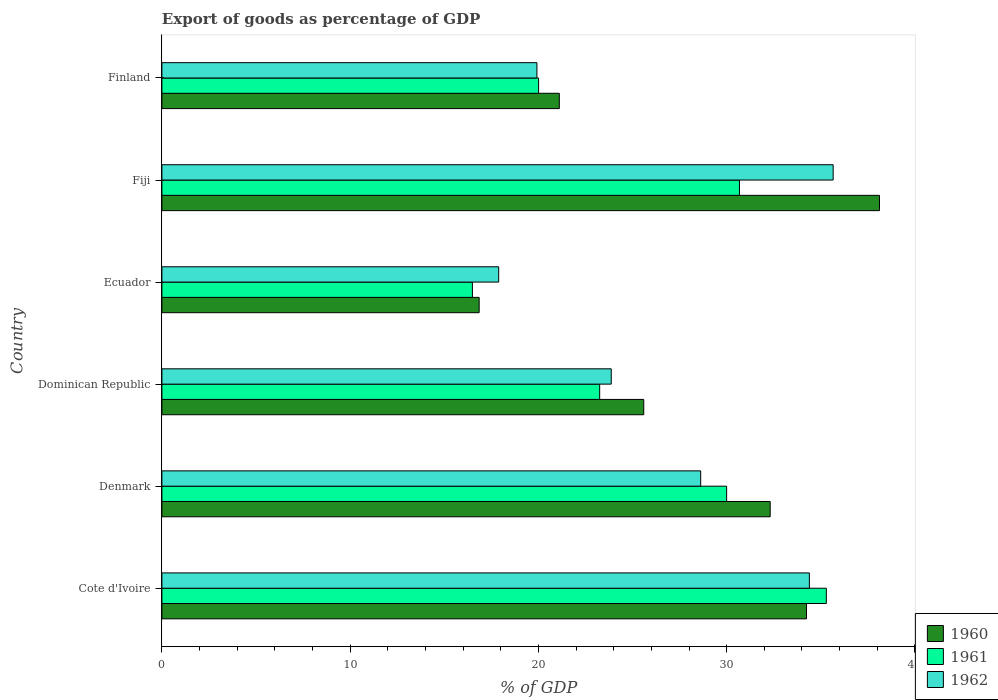How many different coloured bars are there?
Provide a succinct answer. 3. Are the number of bars on each tick of the Y-axis equal?
Provide a succinct answer. Yes. How many bars are there on the 3rd tick from the top?
Offer a terse response. 3. How many bars are there on the 4th tick from the bottom?
Your answer should be compact. 3. What is the label of the 4th group of bars from the top?
Keep it short and to the point. Dominican Republic. What is the export of goods as percentage of GDP in 1961 in Denmark?
Your answer should be compact. 30. Across all countries, what is the maximum export of goods as percentage of GDP in 1962?
Your answer should be very brief. 35.66. Across all countries, what is the minimum export of goods as percentage of GDP in 1961?
Your answer should be very brief. 16.49. In which country was the export of goods as percentage of GDP in 1960 maximum?
Provide a succinct answer. Fiji. In which country was the export of goods as percentage of GDP in 1960 minimum?
Your answer should be compact. Ecuador. What is the total export of goods as percentage of GDP in 1962 in the graph?
Provide a succinct answer. 160.35. What is the difference between the export of goods as percentage of GDP in 1962 in Dominican Republic and that in Fiji?
Your answer should be very brief. -11.79. What is the difference between the export of goods as percentage of GDP in 1961 in Finland and the export of goods as percentage of GDP in 1960 in Dominican Republic?
Ensure brevity in your answer.  -5.59. What is the average export of goods as percentage of GDP in 1961 per country?
Your answer should be very brief. 25.95. What is the difference between the export of goods as percentage of GDP in 1960 and export of goods as percentage of GDP in 1962 in Denmark?
Your response must be concise. 3.69. What is the ratio of the export of goods as percentage of GDP in 1960 in Denmark to that in Dominican Republic?
Your answer should be very brief. 1.26. Is the difference between the export of goods as percentage of GDP in 1960 in Cote d'Ivoire and Fiji greater than the difference between the export of goods as percentage of GDP in 1962 in Cote d'Ivoire and Fiji?
Your answer should be very brief. No. What is the difference between the highest and the second highest export of goods as percentage of GDP in 1960?
Provide a short and direct response. 3.88. What is the difference between the highest and the lowest export of goods as percentage of GDP in 1960?
Make the answer very short. 21.26. In how many countries, is the export of goods as percentage of GDP in 1961 greater than the average export of goods as percentage of GDP in 1961 taken over all countries?
Offer a very short reply. 3. Is the sum of the export of goods as percentage of GDP in 1960 in Dominican Republic and Ecuador greater than the maximum export of goods as percentage of GDP in 1962 across all countries?
Offer a very short reply. Yes. What does the 3rd bar from the top in Finland represents?
Offer a very short reply. 1960. What does the 2nd bar from the bottom in Cote d'Ivoire represents?
Give a very brief answer. 1961. Is it the case that in every country, the sum of the export of goods as percentage of GDP in 1960 and export of goods as percentage of GDP in 1962 is greater than the export of goods as percentage of GDP in 1961?
Provide a succinct answer. Yes. Are all the bars in the graph horizontal?
Your answer should be compact. Yes. Does the graph contain grids?
Provide a short and direct response. No. What is the title of the graph?
Offer a very short reply. Export of goods as percentage of GDP. Does "1975" appear as one of the legend labels in the graph?
Provide a succinct answer. No. What is the label or title of the X-axis?
Your answer should be compact. % of GDP. What is the label or title of the Y-axis?
Your response must be concise. Country. What is the % of GDP of 1960 in Cote d'Ivoire?
Keep it short and to the point. 34.24. What is the % of GDP of 1961 in Cote d'Ivoire?
Make the answer very short. 35.29. What is the % of GDP of 1962 in Cote d'Ivoire?
Offer a very short reply. 34.39. What is the % of GDP of 1960 in Denmark?
Your answer should be compact. 32.31. What is the % of GDP in 1961 in Denmark?
Your answer should be compact. 30. What is the % of GDP of 1962 in Denmark?
Give a very brief answer. 28.62. What is the % of GDP in 1960 in Dominican Republic?
Provide a succinct answer. 25.59. What is the % of GDP of 1961 in Dominican Republic?
Make the answer very short. 23.25. What is the % of GDP of 1962 in Dominican Republic?
Your response must be concise. 23.87. What is the % of GDP in 1960 in Ecuador?
Give a very brief answer. 16.85. What is the % of GDP in 1961 in Ecuador?
Your answer should be compact. 16.49. What is the % of GDP of 1962 in Ecuador?
Provide a succinct answer. 17.89. What is the % of GDP of 1960 in Fiji?
Ensure brevity in your answer.  38.12. What is the % of GDP of 1961 in Fiji?
Provide a succinct answer. 30.68. What is the % of GDP in 1962 in Fiji?
Keep it short and to the point. 35.66. What is the % of GDP in 1960 in Finland?
Your response must be concise. 21.11. What is the % of GDP of 1961 in Finland?
Your answer should be compact. 20.01. What is the % of GDP of 1962 in Finland?
Ensure brevity in your answer.  19.92. Across all countries, what is the maximum % of GDP of 1960?
Offer a terse response. 38.12. Across all countries, what is the maximum % of GDP in 1961?
Offer a terse response. 35.29. Across all countries, what is the maximum % of GDP of 1962?
Your response must be concise. 35.66. Across all countries, what is the minimum % of GDP in 1960?
Your response must be concise. 16.85. Across all countries, what is the minimum % of GDP in 1961?
Offer a terse response. 16.49. Across all countries, what is the minimum % of GDP of 1962?
Ensure brevity in your answer.  17.89. What is the total % of GDP of 1960 in the graph?
Ensure brevity in your answer.  168.22. What is the total % of GDP of 1961 in the graph?
Your answer should be compact. 155.72. What is the total % of GDP in 1962 in the graph?
Give a very brief answer. 160.35. What is the difference between the % of GDP in 1960 in Cote d'Ivoire and that in Denmark?
Give a very brief answer. 1.93. What is the difference between the % of GDP of 1961 in Cote d'Ivoire and that in Denmark?
Your answer should be very brief. 5.3. What is the difference between the % of GDP of 1962 in Cote d'Ivoire and that in Denmark?
Offer a terse response. 5.77. What is the difference between the % of GDP of 1960 in Cote d'Ivoire and that in Dominican Republic?
Provide a short and direct response. 8.64. What is the difference between the % of GDP in 1961 in Cote d'Ivoire and that in Dominican Republic?
Make the answer very short. 12.04. What is the difference between the % of GDP of 1962 in Cote d'Ivoire and that in Dominican Republic?
Provide a short and direct response. 10.52. What is the difference between the % of GDP in 1960 in Cote d'Ivoire and that in Ecuador?
Give a very brief answer. 17.39. What is the difference between the % of GDP of 1961 in Cote d'Ivoire and that in Ecuador?
Offer a terse response. 18.8. What is the difference between the % of GDP of 1962 in Cote d'Ivoire and that in Ecuador?
Your response must be concise. 16.5. What is the difference between the % of GDP in 1960 in Cote d'Ivoire and that in Fiji?
Your answer should be very brief. -3.88. What is the difference between the % of GDP of 1961 in Cote d'Ivoire and that in Fiji?
Provide a succinct answer. 4.61. What is the difference between the % of GDP in 1962 in Cote d'Ivoire and that in Fiji?
Ensure brevity in your answer.  -1.26. What is the difference between the % of GDP in 1960 in Cote d'Ivoire and that in Finland?
Your response must be concise. 13.13. What is the difference between the % of GDP of 1961 in Cote d'Ivoire and that in Finland?
Keep it short and to the point. 15.28. What is the difference between the % of GDP in 1962 in Cote d'Ivoire and that in Finland?
Ensure brevity in your answer.  14.47. What is the difference between the % of GDP of 1960 in Denmark and that in Dominican Republic?
Offer a terse response. 6.72. What is the difference between the % of GDP in 1961 in Denmark and that in Dominican Republic?
Your answer should be very brief. 6.74. What is the difference between the % of GDP in 1962 in Denmark and that in Dominican Republic?
Your answer should be compact. 4.75. What is the difference between the % of GDP in 1960 in Denmark and that in Ecuador?
Your response must be concise. 15.46. What is the difference between the % of GDP in 1961 in Denmark and that in Ecuador?
Your answer should be very brief. 13.5. What is the difference between the % of GDP of 1962 in Denmark and that in Ecuador?
Offer a terse response. 10.73. What is the difference between the % of GDP of 1960 in Denmark and that in Fiji?
Your answer should be very brief. -5.81. What is the difference between the % of GDP in 1961 in Denmark and that in Fiji?
Offer a very short reply. -0.68. What is the difference between the % of GDP in 1962 in Denmark and that in Fiji?
Provide a short and direct response. -7.04. What is the difference between the % of GDP in 1960 in Denmark and that in Finland?
Ensure brevity in your answer.  11.2. What is the difference between the % of GDP in 1961 in Denmark and that in Finland?
Make the answer very short. 9.99. What is the difference between the % of GDP in 1962 in Denmark and that in Finland?
Offer a terse response. 8.7. What is the difference between the % of GDP of 1960 in Dominican Republic and that in Ecuador?
Your answer should be very brief. 8.74. What is the difference between the % of GDP in 1961 in Dominican Republic and that in Ecuador?
Your answer should be very brief. 6.76. What is the difference between the % of GDP in 1962 in Dominican Republic and that in Ecuador?
Offer a terse response. 5.98. What is the difference between the % of GDP in 1960 in Dominican Republic and that in Fiji?
Make the answer very short. -12.52. What is the difference between the % of GDP of 1961 in Dominican Republic and that in Fiji?
Your answer should be compact. -7.42. What is the difference between the % of GDP in 1962 in Dominican Republic and that in Fiji?
Your answer should be very brief. -11.79. What is the difference between the % of GDP of 1960 in Dominican Republic and that in Finland?
Provide a short and direct response. 4.49. What is the difference between the % of GDP in 1961 in Dominican Republic and that in Finland?
Provide a short and direct response. 3.24. What is the difference between the % of GDP in 1962 in Dominican Republic and that in Finland?
Your response must be concise. 3.95. What is the difference between the % of GDP in 1960 in Ecuador and that in Fiji?
Your answer should be very brief. -21.26. What is the difference between the % of GDP in 1961 in Ecuador and that in Fiji?
Your response must be concise. -14.18. What is the difference between the % of GDP in 1962 in Ecuador and that in Fiji?
Offer a terse response. -17.77. What is the difference between the % of GDP in 1960 in Ecuador and that in Finland?
Offer a terse response. -4.26. What is the difference between the % of GDP in 1961 in Ecuador and that in Finland?
Make the answer very short. -3.52. What is the difference between the % of GDP of 1962 in Ecuador and that in Finland?
Ensure brevity in your answer.  -2.03. What is the difference between the % of GDP in 1960 in Fiji and that in Finland?
Provide a succinct answer. 17.01. What is the difference between the % of GDP of 1961 in Fiji and that in Finland?
Give a very brief answer. 10.67. What is the difference between the % of GDP in 1962 in Fiji and that in Finland?
Ensure brevity in your answer.  15.74. What is the difference between the % of GDP in 1960 in Cote d'Ivoire and the % of GDP in 1961 in Denmark?
Your answer should be very brief. 4.24. What is the difference between the % of GDP of 1960 in Cote d'Ivoire and the % of GDP of 1962 in Denmark?
Ensure brevity in your answer.  5.62. What is the difference between the % of GDP of 1961 in Cote d'Ivoire and the % of GDP of 1962 in Denmark?
Provide a short and direct response. 6.67. What is the difference between the % of GDP of 1960 in Cote d'Ivoire and the % of GDP of 1961 in Dominican Republic?
Your response must be concise. 10.99. What is the difference between the % of GDP of 1960 in Cote d'Ivoire and the % of GDP of 1962 in Dominican Republic?
Provide a succinct answer. 10.37. What is the difference between the % of GDP in 1961 in Cote d'Ivoire and the % of GDP in 1962 in Dominican Republic?
Give a very brief answer. 11.42. What is the difference between the % of GDP in 1960 in Cote d'Ivoire and the % of GDP in 1961 in Ecuador?
Keep it short and to the point. 17.75. What is the difference between the % of GDP of 1960 in Cote d'Ivoire and the % of GDP of 1962 in Ecuador?
Offer a very short reply. 16.35. What is the difference between the % of GDP of 1961 in Cote d'Ivoire and the % of GDP of 1962 in Ecuador?
Your answer should be very brief. 17.4. What is the difference between the % of GDP of 1960 in Cote d'Ivoire and the % of GDP of 1961 in Fiji?
Ensure brevity in your answer.  3.56. What is the difference between the % of GDP of 1960 in Cote d'Ivoire and the % of GDP of 1962 in Fiji?
Give a very brief answer. -1.42. What is the difference between the % of GDP in 1961 in Cote d'Ivoire and the % of GDP in 1962 in Fiji?
Your answer should be very brief. -0.36. What is the difference between the % of GDP of 1960 in Cote d'Ivoire and the % of GDP of 1961 in Finland?
Provide a succinct answer. 14.23. What is the difference between the % of GDP in 1960 in Cote d'Ivoire and the % of GDP in 1962 in Finland?
Offer a terse response. 14.32. What is the difference between the % of GDP of 1961 in Cote d'Ivoire and the % of GDP of 1962 in Finland?
Offer a very short reply. 15.37. What is the difference between the % of GDP of 1960 in Denmark and the % of GDP of 1961 in Dominican Republic?
Offer a terse response. 9.06. What is the difference between the % of GDP in 1960 in Denmark and the % of GDP in 1962 in Dominican Republic?
Make the answer very short. 8.44. What is the difference between the % of GDP of 1961 in Denmark and the % of GDP of 1962 in Dominican Republic?
Give a very brief answer. 6.13. What is the difference between the % of GDP in 1960 in Denmark and the % of GDP in 1961 in Ecuador?
Ensure brevity in your answer.  15.82. What is the difference between the % of GDP of 1960 in Denmark and the % of GDP of 1962 in Ecuador?
Keep it short and to the point. 14.42. What is the difference between the % of GDP in 1961 in Denmark and the % of GDP in 1962 in Ecuador?
Offer a terse response. 12.11. What is the difference between the % of GDP in 1960 in Denmark and the % of GDP in 1961 in Fiji?
Your response must be concise. 1.63. What is the difference between the % of GDP of 1960 in Denmark and the % of GDP of 1962 in Fiji?
Your response must be concise. -3.35. What is the difference between the % of GDP of 1961 in Denmark and the % of GDP of 1962 in Fiji?
Your answer should be very brief. -5.66. What is the difference between the % of GDP of 1960 in Denmark and the % of GDP of 1961 in Finland?
Your response must be concise. 12.3. What is the difference between the % of GDP in 1960 in Denmark and the % of GDP in 1962 in Finland?
Provide a short and direct response. 12.39. What is the difference between the % of GDP in 1961 in Denmark and the % of GDP in 1962 in Finland?
Provide a short and direct response. 10.08. What is the difference between the % of GDP of 1960 in Dominican Republic and the % of GDP of 1961 in Ecuador?
Your answer should be very brief. 9.1. What is the difference between the % of GDP in 1960 in Dominican Republic and the % of GDP in 1962 in Ecuador?
Give a very brief answer. 7.71. What is the difference between the % of GDP in 1961 in Dominican Republic and the % of GDP in 1962 in Ecuador?
Provide a short and direct response. 5.36. What is the difference between the % of GDP of 1960 in Dominican Republic and the % of GDP of 1961 in Fiji?
Offer a terse response. -5.08. What is the difference between the % of GDP in 1960 in Dominican Republic and the % of GDP in 1962 in Fiji?
Ensure brevity in your answer.  -10.06. What is the difference between the % of GDP of 1961 in Dominican Republic and the % of GDP of 1962 in Fiji?
Your answer should be compact. -12.4. What is the difference between the % of GDP of 1960 in Dominican Republic and the % of GDP of 1961 in Finland?
Offer a terse response. 5.59. What is the difference between the % of GDP of 1960 in Dominican Republic and the % of GDP of 1962 in Finland?
Offer a terse response. 5.67. What is the difference between the % of GDP of 1961 in Dominican Republic and the % of GDP of 1962 in Finland?
Provide a succinct answer. 3.33. What is the difference between the % of GDP in 1960 in Ecuador and the % of GDP in 1961 in Fiji?
Your answer should be compact. -13.83. What is the difference between the % of GDP in 1960 in Ecuador and the % of GDP in 1962 in Fiji?
Provide a short and direct response. -18.8. What is the difference between the % of GDP in 1961 in Ecuador and the % of GDP in 1962 in Fiji?
Give a very brief answer. -19.16. What is the difference between the % of GDP of 1960 in Ecuador and the % of GDP of 1961 in Finland?
Provide a succinct answer. -3.16. What is the difference between the % of GDP of 1960 in Ecuador and the % of GDP of 1962 in Finland?
Offer a terse response. -3.07. What is the difference between the % of GDP in 1961 in Ecuador and the % of GDP in 1962 in Finland?
Offer a terse response. -3.43. What is the difference between the % of GDP in 1960 in Fiji and the % of GDP in 1961 in Finland?
Give a very brief answer. 18.11. What is the difference between the % of GDP of 1960 in Fiji and the % of GDP of 1962 in Finland?
Your response must be concise. 18.2. What is the difference between the % of GDP of 1961 in Fiji and the % of GDP of 1962 in Finland?
Keep it short and to the point. 10.76. What is the average % of GDP of 1960 per country?
Offer a terse response. 28.04. What is the average % of GDP in 1961 per country?
Provide a succinct answer. 25.95. What is the average % of GDP in 1962 per country?
Provide a short and direct response. 26.72. What is the difference between the % of GDP in 1960 and % of GDP in 1961 in Cote d'Ivoire?
Your response must be concise. -1.05. What is the difference between the % of GDP in 1960 and % of GDP in 1962 in Cote d'Ivoire?
Your answer should be very brief. -0.15. What is the difference between the % of GDP of 1961 and % of GDP of 1962 in Cote d'Ivoire?
Your answer should be very brief. 0.9. What is the difference between the % of GDP of 1960 and % of GDP of 1961 in Denmark?
Your answer should be compact. 2.31. What is the difference between the % of GDP of 1960 and % of GDP of 1962 in Denmark?
Provide a succinct answer. 3.69. What is the difference between the % of GDP of 1961 and % of GDP of 1962 in Denmark?
Your response must be concise. 1.38. What is the difference between the % of GDP of 1960 and % of GDP of 1961 in Dominican Republic?
Provide a short and direct response. 2.34. What is the difference between the % of GDP in 1960 and % of GDP in 1962 in Dominican Republic?
Your answer should be very brief. 1.73. What is the difference between the % of GDP in 1961 and % of GDP in 1962 in Dominican Republic?
Provide a succinct answer. -0.62. What is the difference between the % of GDP in 1960 and % of GDP in 1961 in Ecuador?
Ensure brevity in your answer.  0.36. What is the difference between the % of GDP in 1960 and % of GDP in 1962 in Ecuador?
Your response must be concise. -1.04. What is the difference between the % of GDP of 1961 and % of GDP of 1962 in Ecuador?
Make the answer very short. -1.4. What is the difference between the % of GDP in 1960 and % of GDP in 1961 in Fiji?
Your response must be concise. 7.44. What is the difference between the % of GDP of 1960 and % of GDP of 1962 in Fiji?
Your response must be concise. 2.46. What is the difference between the % of GDP in 1961 and % of GDP in 1962 in Fiji?
Make the answer very short. -4.98. What is the difference between the % of GDP of 1960 and % of GDP of 1961 in Finland?
Offer a terse response. 1.1. What is the difference between the % of GDP of 1960 and % of GDP of 1962 in Finland?
Keep it short and to the point. 1.19. What is the difference between the % of GDP in 1961 and % of GDP in 1962 in Finland?
Provide a short and direct response. 0.09. What is the ratio of the % of GDP of 1960 in Cote d'Ivoire to that in Denmark?
Provide a short and direct response. 1.06. What is the ratio of the % of GDP of 1961 in Cote d'Ivoire to that in Denmark?
Make the answer very short. 1.18. What is the ratio of the % of GDP of 1962 in Cote d'Ivoire to that in Denmark?
Provide a short and direct response. 1.2. What is the ratio of the % of GDP in 1960 in Cote d'Ivoire to that in Dominican Republic?
Provide a succinct answer. 1.34. What is the ratio of the % of GDP of 1961 in Cote d'Ivoire to that in Dominican Republic?
Your answer should be very brief. 1.52. What is the ratio of the % of GDP of 1962 in Cote d'Ivoire to that in Dominican Republic?
Provide a succinct answer. 1.44. What is the ratio of the % of GDP in 1960 in Cote d'Ivoire to that in Ecuador?
Offer a very short reply. 2.03. What is the ratio of the % of GDP of 1961 in Cote d'Ivoire to that in Ecuador?
Provide a succinct answer. 2.14. What is the ratio of the % of GDP of 1962 in Cote d'Ivoire to that in Ecuador?
Give a very brief answer. 1.92. What is the ratio of the % of GDP of 1960 in Cote d'Ivoire to that in Fiji?
Offer a terse response. 0.9. What is the ratio of the % of GDP in 1961 in Cote d'Ivoire to that in Fiji?
Keep it short and to the point. 1.15. What is the ratio of the % of GDP of 1962 in Cote d'Ivoire to that in Fiji?
Give a very brief answer. 0.96. What is the ratio of the % of GDP in 1960 in Cote d'Ivoire to that in Finland?
Give a very brief answer. 1.62. What is the ratio of the % of GDP in 1961 in Cote d'Ivoire to that in Finland?
Give a very brief answer. 1.76. What is the ratio of the % of GDP in 1962 in Cote d'Ivoire to that in Finland?
Provide a succinct answer. 1.73. What is the ratio of the % of GDP in 1960 in Denmark to that in Dominican Republic?
Offer a very short reply. 1.26. What is the ratio of the % of GDP of 1961 in Denmark to that in Dominican Republic?
Your answer should be compact. 1.29. What is the ratio of the % of GDP in 1962 in Denmark to that in Dominican Republic?
Provide a succinct answer. 1.2. What is the ratio of the % of GDP of 1960 in Denmark to that in Ecuador?
Your response must be concise. 1.92. What is the ratio of the % of GDP of 1961 in Denmark to that in Ecuador?
Your answer should be very brief. 1.82. What is the ratio of the % of GDP of 1962 in Denmark to that in Ecuador?
Give a very brief answer. 1.6. What is the ratio of the % of GDP in 1960 in Denmark to that in Fiji?
Give a very brief answer. 0.85. What is the ratio of the % of GDP of 1961 in Denmark to that in Fiji?
Provide a succinct answer. 0.98. What is the ratio of the % of GDP in 1962 in Denmark to that in Fiji?
Your response must be concise. 0.8. What is the ratio of the % of GDP of 1960 in Denmark to that in Finland?
Your answer should be compact. 1.53. What is the ratio of the % of GDP of 1961 in Denmark to that in Finland?
Ensure brevity in your answer.  1.5. What is the ratio of the % of GDP of 1962 in Denmark to that in Finland?
Ensure brevity in your answer.  1.44. What is the ratio of the % of GDP of 1960 in Dominican Republic to that in Ecuador?
Give a very brief answer. 1.52. What is the ratio of the % of GDP of 1961 in Dominican Republic to that in Ecuador?
Keep it short and to the point. 1.41. What is the ratio of the % of GDP of 1962 in Dominican Republic to that in Ecuador?
Ensure brevity in your answer.  1.33. What is the ratio of the % of GDP in 1960 in Dominican Republic to that in Fiji?
Give a very brief answer. 0.67. What is the ratio of the % of GDP of 1961 in Dominican Republic to that in Fiji?
Your answer should be very brief. 0.76. What is the ratio of the % of GDP of 1962 in Dominican Republic to that in Fiji?
Ensure brevity in your answer.  0.67. What is the ratio of the % of GDP of 1960 in Dominican Republic to that in Finland?
Provide a short and direct response. 1.21. What is the ratio of the % of GDP in 1961 in Dominican Republic to that in Finland?
Make the answer very short. 1.16. What is the ratio of the % of GDP of 1962 in Dominican Republic to that in Finland?
Your response must be concise. 1.2. What is the ratio of the % of GDP in 1960 in Ecuador to that in Fiji?
Your answer should be very brief. 0.44. What is the ratio of the % of GDP of 1961 in Ecuador to that in Fiji?
Offer a very short reply. 0.54. What is the ratio of the % of GDP in 1962 in Ecuador to that in Fiji?
Offer a terse response. 0.5. What is the ratio of the % of GDP in 1960 in Ecuador to that in Finland?
Your response must be concise. 0.8. What is the ratio of the % of GDP of 1961 in Ecuador to that in Finland?
Your response must be concise. 0.82. What is the ratio of the % of GDP in 1962 in Ecuador to that in Finland?
Your response must be concise. 0.9. What is the ratio of the % of GDP of 1960 in Fiji to that in Finland?
Give a very brief answer. 1.81. What is the ratio of the % of GDP in 1961 in Fiji to that in Finland?
Provide a short and direct response. 1.53. What is the ratio of the % of GDP of 1962 in Fiji to that in Finland?
Ensure brevity in your answer.  1.79. What is the difference between the highest and the second highest % of GDP in 1960?
Offer a very short reply. 3.88. What is the difference between the highest and the second highest % of GDP in 1961?
Make the answer very short. 4.61. What is the difference between the highest and the second highest % of GDP in 1962?
Provide a succinct answer. 1.26. What is the difference between the highest and the lowest % of GDP of 1960?
Make the answer very short. 21.26. What is the difference between the highest and the lowest % of GDP of 1961?
Offer a very short reply. 18.8. What is the difference between the highest and the lowest % of GDP of 1962?
Your answer should be very brief. 17.77. 